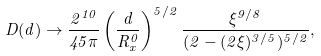Convert formula to latex. <formula><loc_0><loc_0><loc_500><loc_500>D ( d ) \to \frac { 2 ^ { 1 0 } } { 4 5 \pi } \left ( \frac { d } { R _ { x } ^ { 0 } } \right ) ^ { 5 / 2 } \frac { \xi ^ { 9 / 8 } } { ( 2 - ( 2 \xi ) ^ { 3 / 5 } ) ^ { 5 / 2 } } ,</formula> 